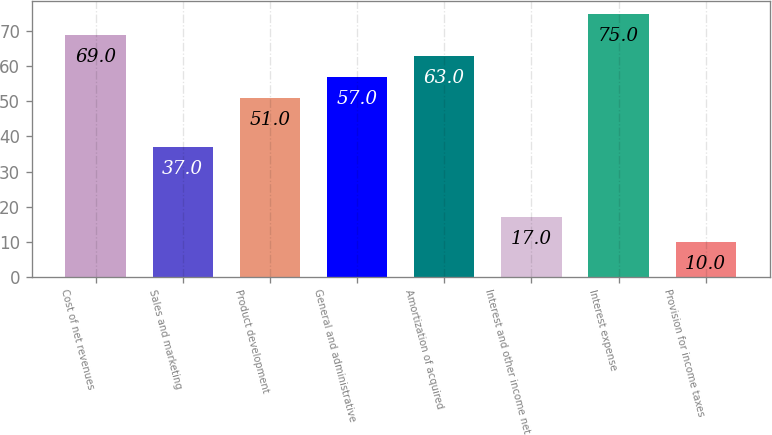<chart> <loc_0><loc_0><loc_500><loc_500><bar_chart><fcel>Cost of net revenues<fcel>Sales and marketing<fcel>Product development<fcel>General and administrative<fcel>Amortization of acquired<fcel>Interest and other income net<fcel>Interest expense<fcel>Provision for income taxes<nl><fcel>69<fcel>37<fcel>51<fcel>57<fcel>63<fcel>17<fcel>75<fcel>10<nl></chart> 